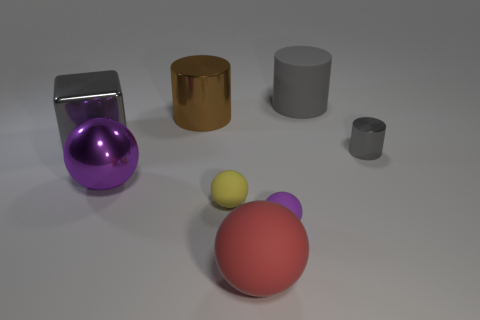Subtract 2 spheres. How many spheres are left? 2 Add 1 purple matte blocks. How many objects exist? 9 Subtract all blocks. How many objects are left? 7 Subtract all purple matte cylinders. Subtract all yellow rubber spheres. How many objects are left? 7 Add 5 big red rubber objects. How many big red rubber objects are left? 6 Add 6 large gray objects. How many large gray objects exist? 8 Subtract 0 purple cubes. How many objects are left? 8 